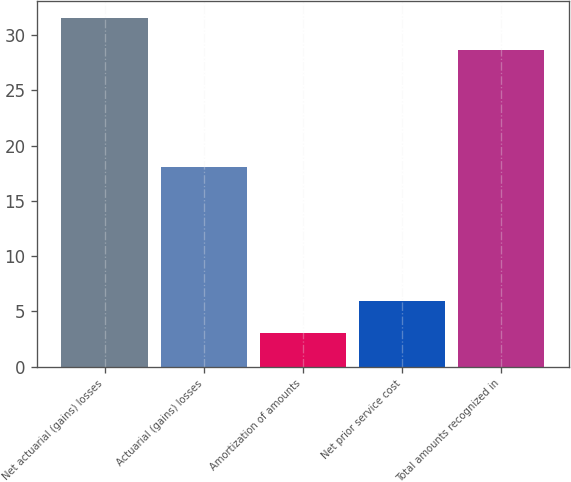Convert chart to OTSL. <chart><loc_0><loc_0><loc_500><loc_500><bar_chart><fcel>Net actuarial (gains) losses<fcel>Actuarial (gains) losses<fcel>Amortization of amounts<fcel>Net prior service cost<fcel>Total amounts recognized in<nl><fcel>31.54<fcel>18.04<fcel>3.04<fcel>5.98<fcel>28.6<nl></chart> 